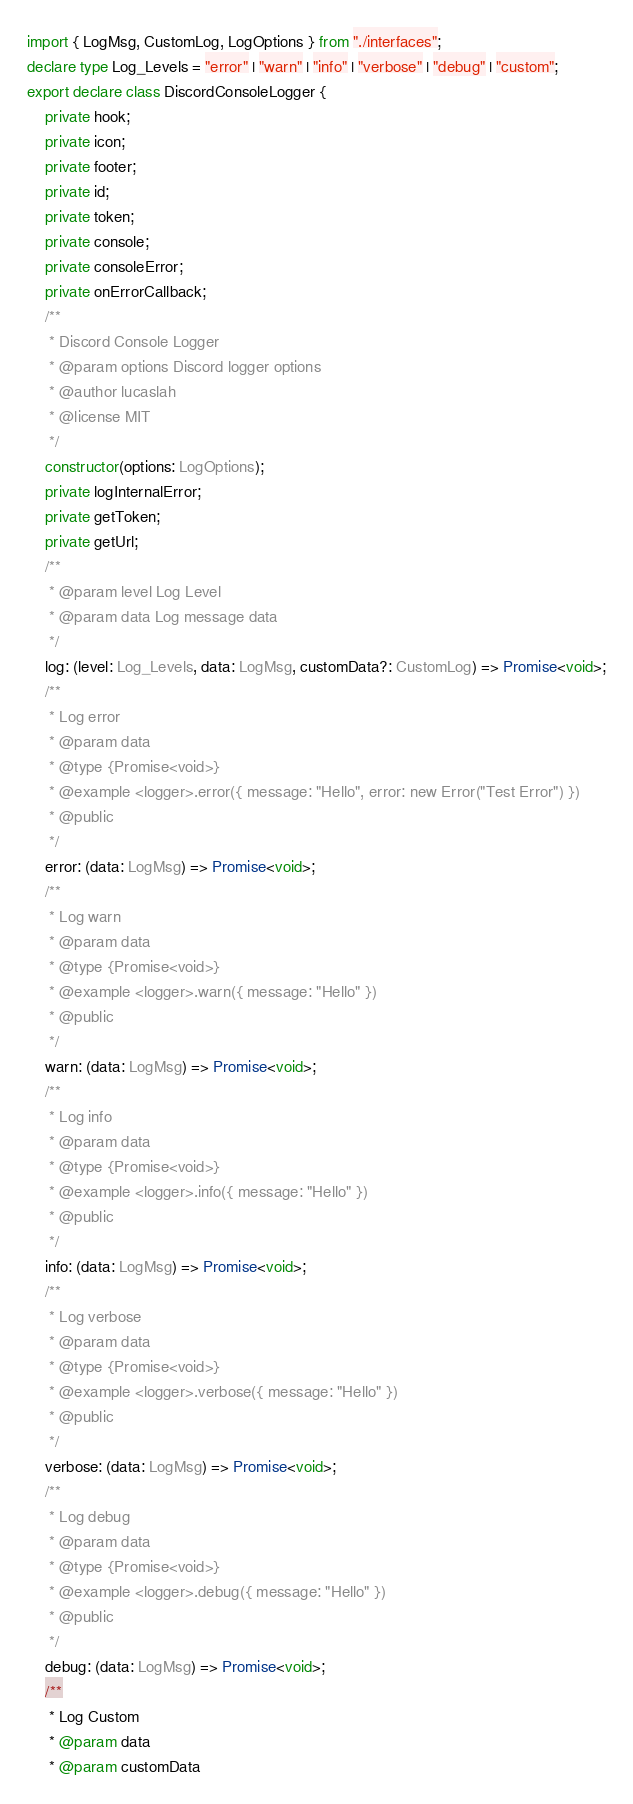<code> <loc_0><loc_0><loc_500><loc_500><_TypeScript_>import { LogMsg, CustomLog, LogOptions } from "./interfaces";
declare type Log_Levels = "error" | "warn" | "info" | "verbose" | "debug" | "custom";
export declare class DiscordConsoleLogger {
    private hook;
    private icon;
    private footer;
    private id;
    private token;
    private console;
    private consoleError;
    private onErrorCallback;
    /**
     * Discord Console Logger
     * @param options Discord logger options
     * @author lucaslah
     * @license MIT
     */
    constructor(options: LogOptions);
    private logInternalError;
    private getToken;
    private getUrl;
    /**
     * @param level Log Level
     * @param data Log message data
     */
    log: (level: Log_Levels, data: LogMsg, customData?: CustomLog) => Promise<void>;
    /**
     * Log error
     * @param data
     * @type {Promise<void>}
     * @example <logger>.error({ message: "Hello", error: new Error("Test Error") })
     * @public
     */
    error: (data: LogMsg) => Promise<void>;
    /**
     * Log warn
     * @param data
     * @type {Promise<void>}
     * @example <logger>.warn({ message: "Hello" })
     * @public
     */
    warn: (data: LogMsg) => Promise<void>;
    /**
     * Log info
     * @param data
     * @type {Promise<void>}
     * @example <logger>.info({ message: "Hello" })
     * @public
     */
    info: (data: LogMsg) => Promise<void>;
    /**
     * Log verbose
     * @param data
     * @type {Promise<void>}
     * @example <logger>.verbose({ message: "Hello" })
     * @public
     */
    verbose: (data: LogMsg) => Promise<void>;
    /**
     * Log debug
     * @param data
     * @type {Promise<void>}
     * @example <logger>.debug({ message: "Hello" })
     * @public
     */
    debug: (data: LogMsg) => Promise<void>;
    /**
     * Log Custom
     * @param data
     * @param customData</code> 